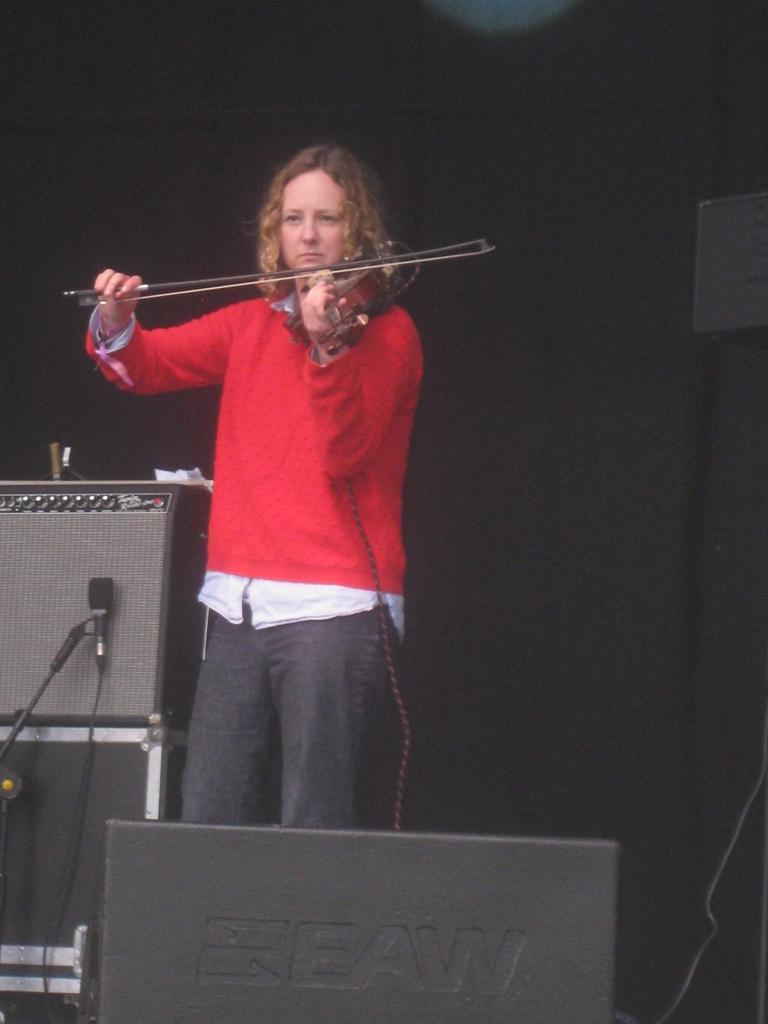In one or two sentences, can you explain what this image depicts? This woman wore red t-shirt and playing violin with stick. In-front of this speaker there is a mic with holder. 